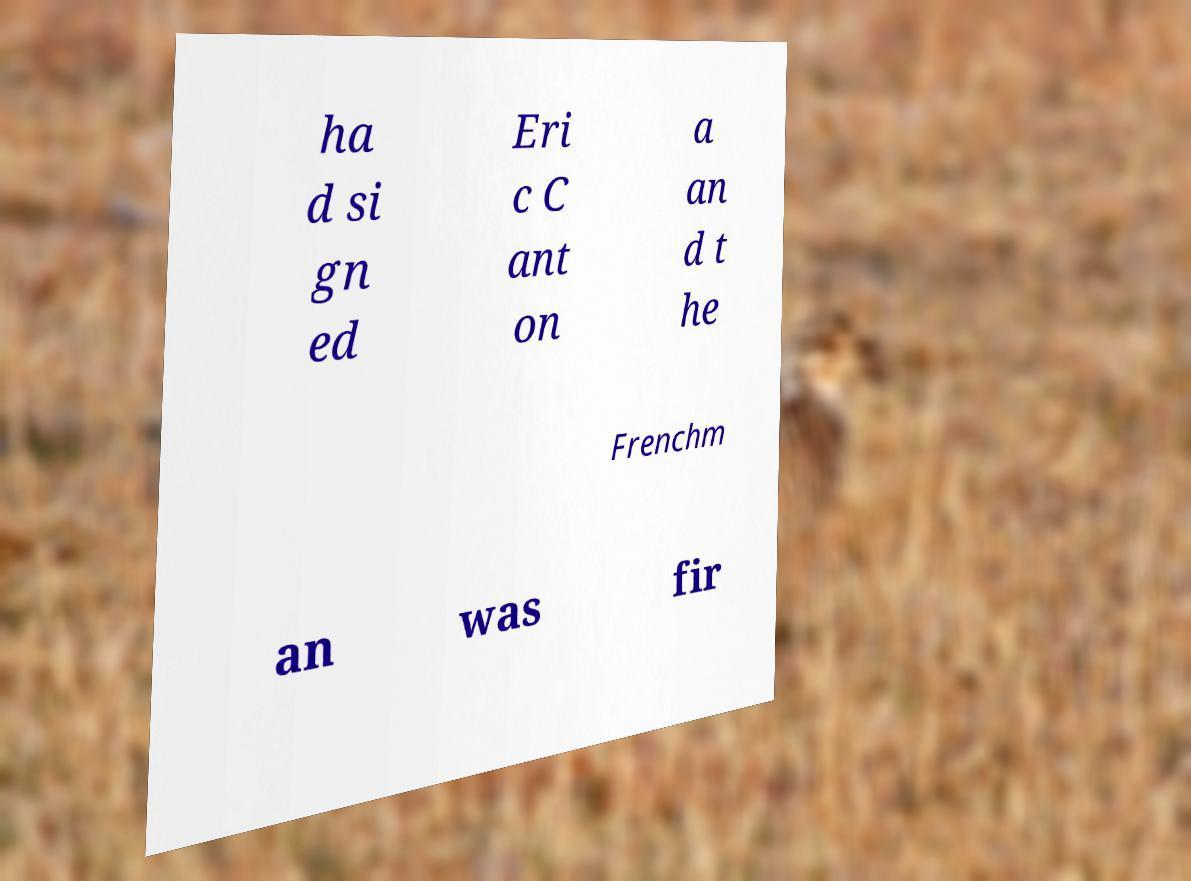Can you accurately transcribe the text from the provided image for me? ha d si gn ed Eri c C ant on a an d t he Frenchm an was fir 